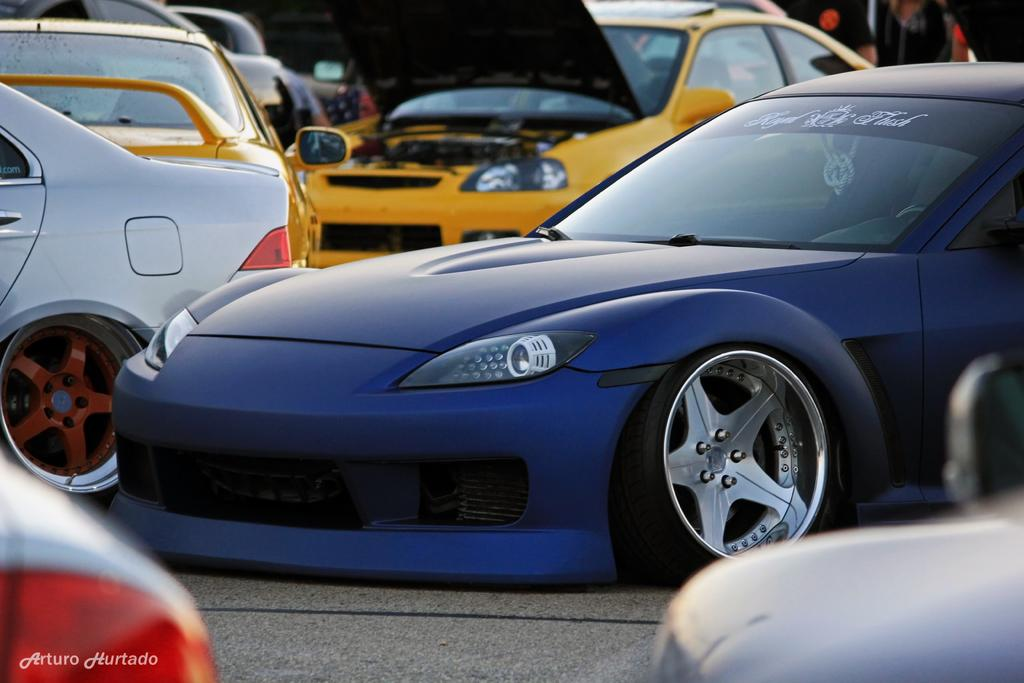What is the main subject of the image? The main subject of the image is a group of vehicles. Where are the vehicles located in the image? The vehicles are on the ground in the image. How many ducks are flying above the vehicles in the image? There are no ducks present in the image; it only features a group of vehicles on the ground. 